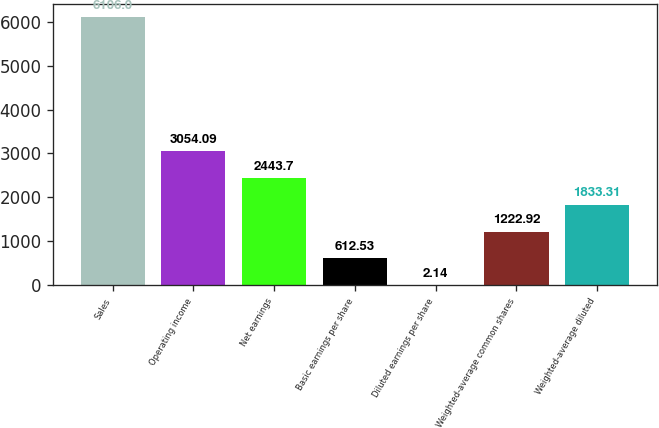<chart> <loc_0><loc_0><loc_500><loc_500><bar_chart><fcel>Sales<fcel>Operating income<fcel>Net earnings<fcel>Basic earnings per share<fcel>Diluted earnings per share<fcel>Weighted-average common shares<fcel>Weighted-average diluted<nl><fcel>6106<fcel>3054.09<fcel>2443.7<fcel>612.53<fcel>2.14<fcel>1222.92<fcel>1833.31<nl></chart> 